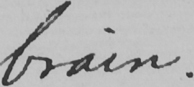Transcribe the text shown in this historical manuscript line. brain. 